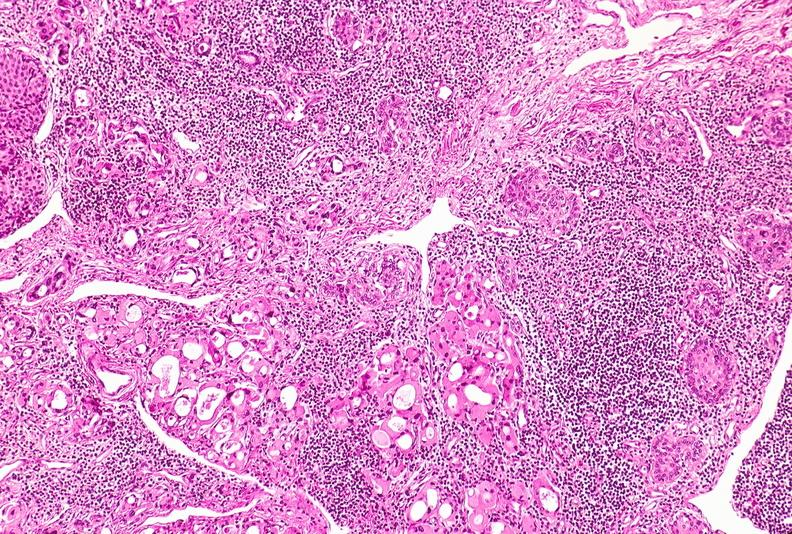s an opened peritoneal cavity cause by fibrous band strangulation present?
Answer the question using a single word or phrase. No 